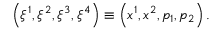Convert formula to latex. <formula><loc_0><loc_0><loc_500><loc_500>\left ( \xi ^ { 1 } , \xi ^ { 2 } , \xi ^ { 3 } , \xi ^ { 4 } \right ) \equiv \left ( x ^ { 1 } , x ^ { 2 } , p _ { 1 } , p _ { 2 } \right ) .</formula> 